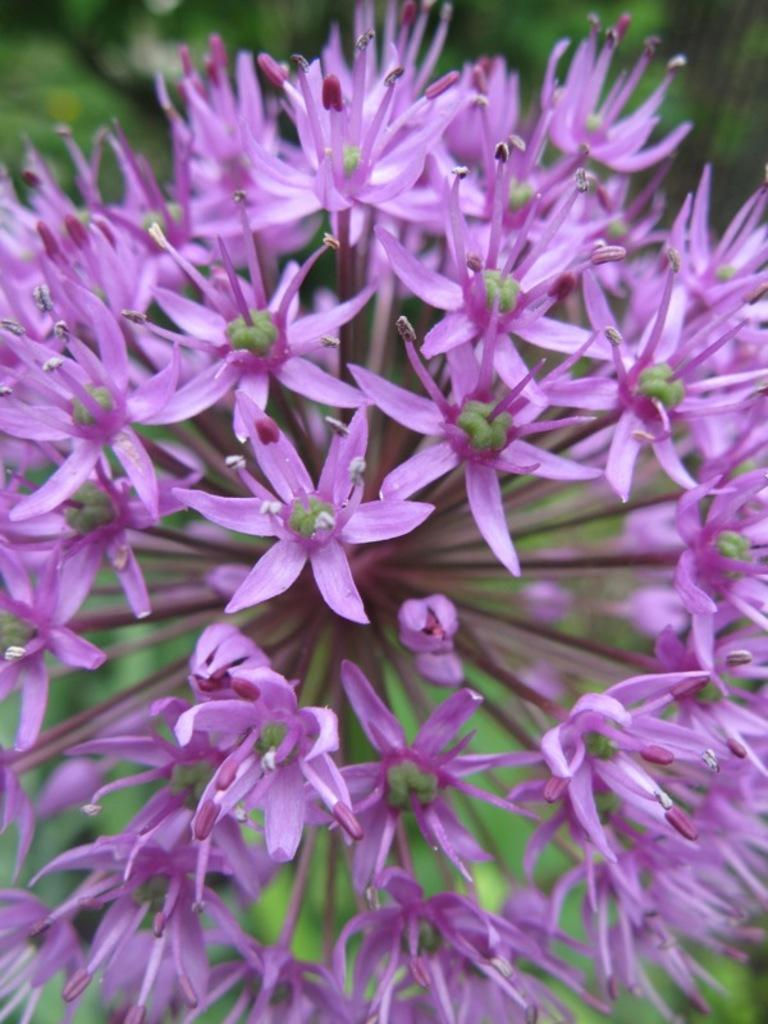What type of plants can be seen in the image? There are flowers in the image. What color are the flowers? The flowers are purple in color. What type of voice can be heard coming from the flowers in the image? There is no voice coming from the flowers in the image, as flowers do not have the ability to produce sound. 